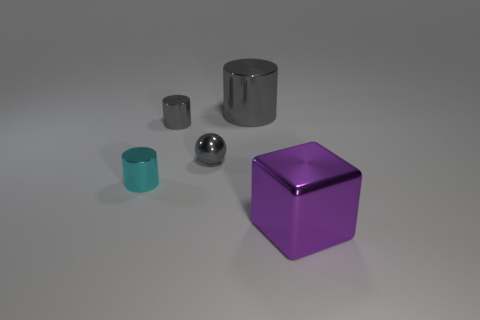There is a cyan object that is the same shape as the large gray thing; what size is it?
Offer a very short reply. Small. Is the shape of the large shiny thing that is in front of the tiny gray sphere the same as  the big gray metallic object?
Your answer should be compact. No. The big metal object that is behind the tiny metal object that is right of the tiny gray shiny cylinder is what color?
Ensure brevity in your answer.  Gray. Are there fewer gray things than small green objects?
Offer a very short reply. No. Is there a big thing made of the same material as the small gray sphere?
Ensure brevity in your answer.  Yes. Is the shape of the small cyan thing the same as the tiny gray shiny thing in front of the tiny gray cylinder?
Keep it short and to the point. No. There is a cyan cylinder; are there any cyan cylinders behind it?
Make the answer very short. No. How many tiny purple shiny things are the same shape as the big gray metal thing?
Give a very brief answer. 0. Do the tiny cyan thing and the big object in front of the tiny cyan cylinder have the same material?
Provide a short and direct response. Yes. What number of yellow rubber balls are there?
Ensure brevity in your answer.  0. 